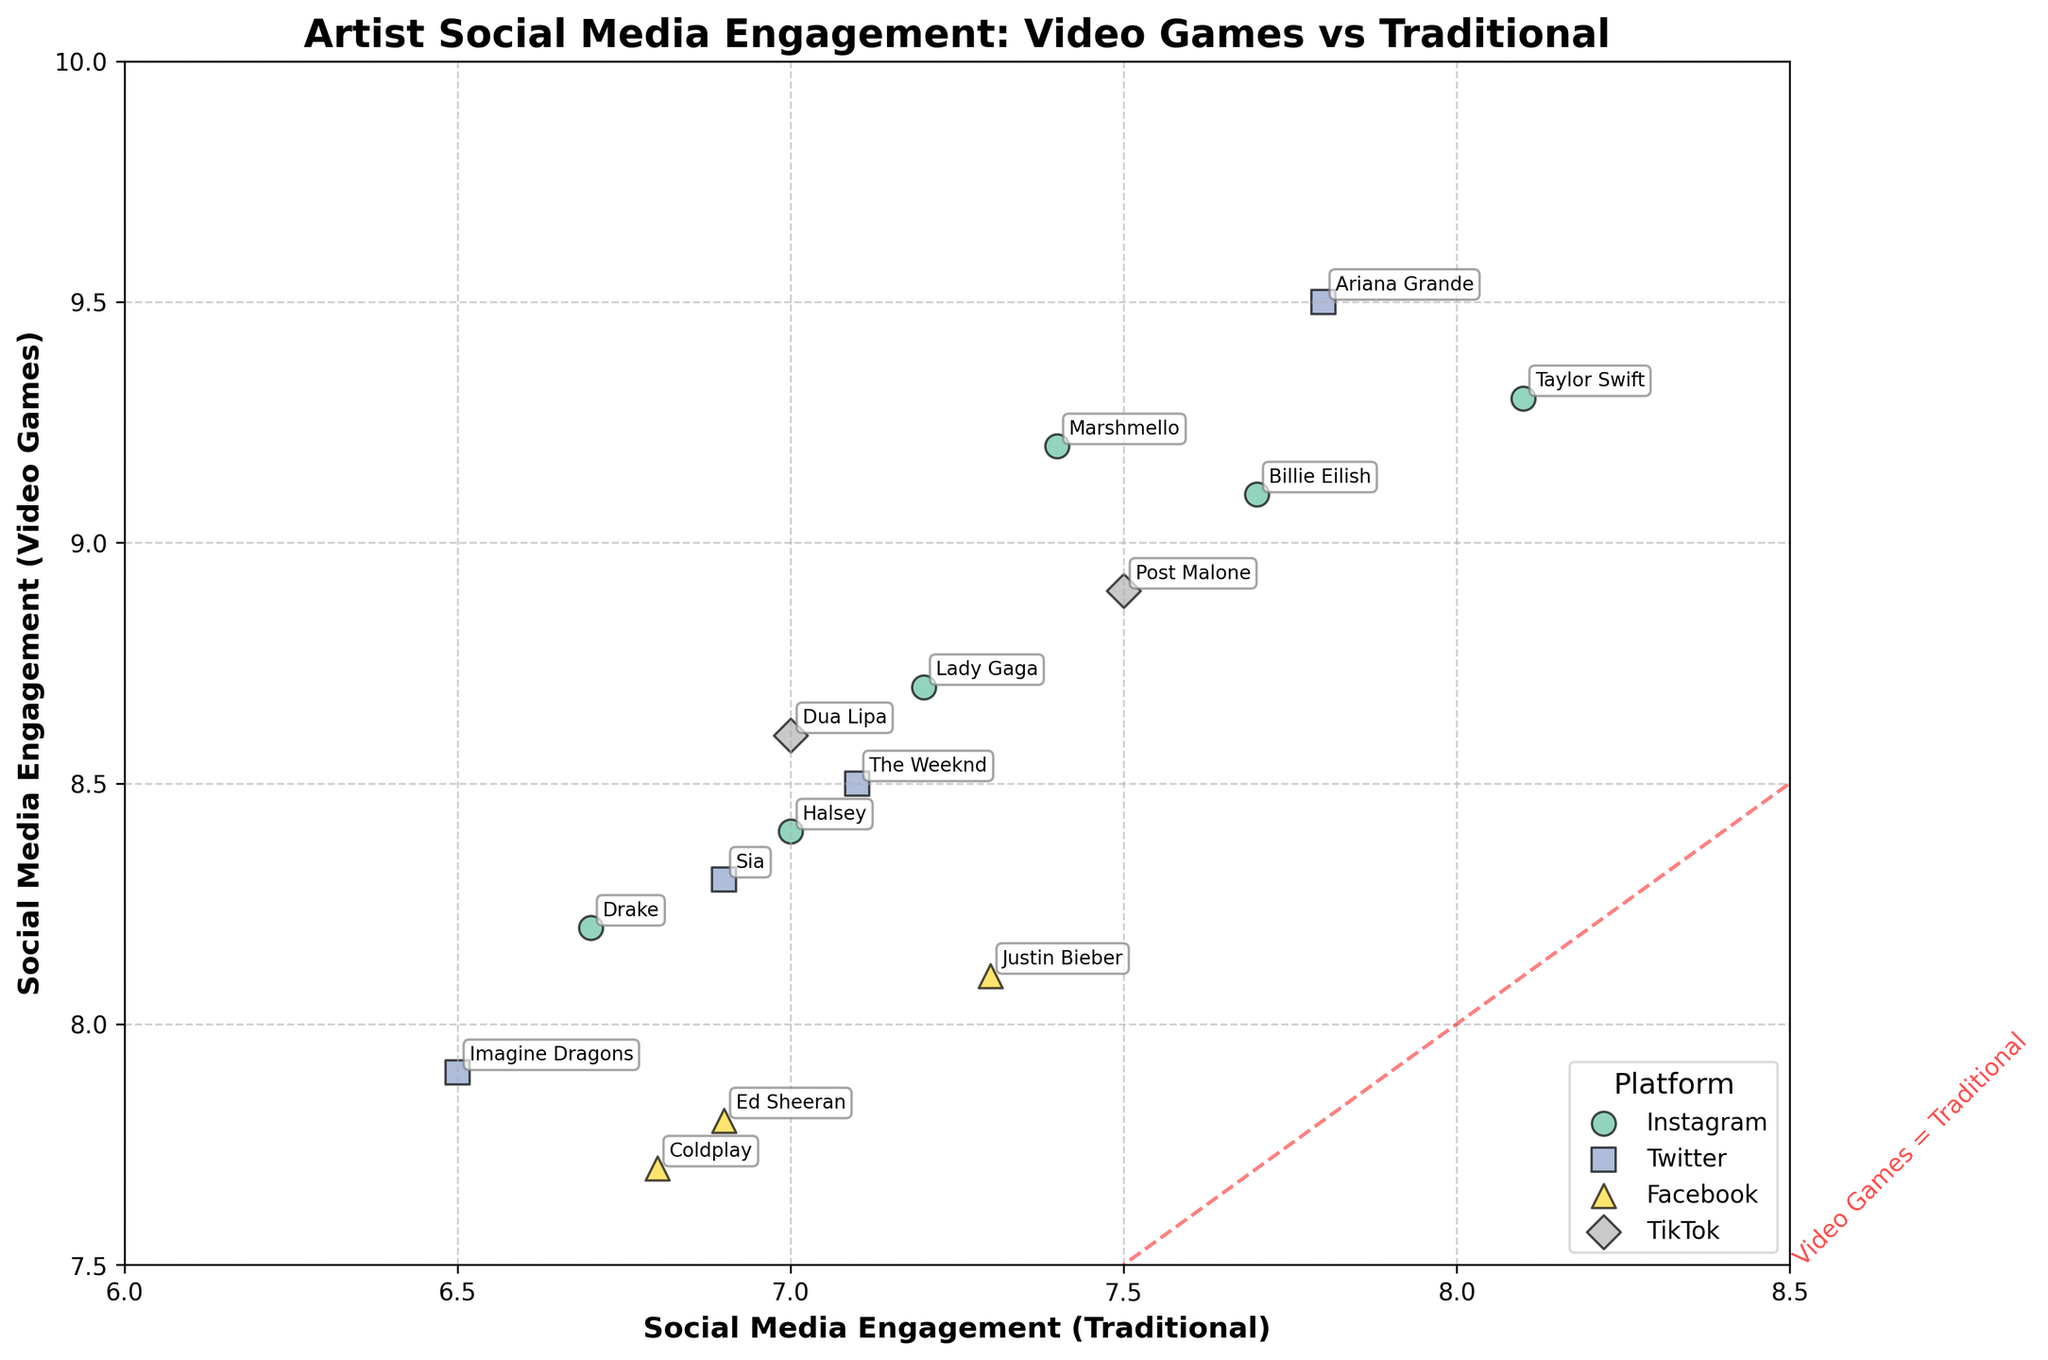How many data points are plotted for artists on Instagram? Count the number of artists associated with Instagram by checking the labels next to the points on the chart. There are 5 artists: Drake, Lady Gaga, Billie Eilish, Taylor Swift, and Marshmello.
Answer: 5 Which artist has the highest social media engagement rate from traditional methods? Review the plotted points and their labels along the horizontal axis (Social Media Engagement - Traditional). Taylor Swift has the highest engagement rate at 8.1.
Answer: Taylor Swift What is the average social media engagement rate for artists promoted through video games? Average the vertical coordinates (Video Game Engagement) of all points. Sum of engagement rates is (8.2 + 9.5 + 7.8 + 8.7 + 8.9 + 9.1 + 8.5 + 9.3 + 8.1 + 8.6 + 7.9 + 9.2 + 7.7 + 8.3 + 8.4) = 129.2. There are 15 data points, so the average is 129.2 / 15 = 8.613.
Answer: 8.61 How does social media engagement from video games compare to traditional methods for Imagine Dragons? Locate Imagine Dragons on the chart: their engagement rate with traditional promotion is 6.5 and with video games is 7.9. Video game engagement is higher (7.9 vs. 6.5).
Answer: Video game engagement is higher Which platform has the highest average video game engagement rate? Calculate the average engagement rate for each platform: 
Instagram: (8.2 + 8.7 + 9.1 + 9.3 + 9.2 + 8.4) / 6
Twitter: (9.5 + 8.5 + 7.9 + 8.3) / 4
Facebook: (7.8 + 8.1 + 7.7) / 3
TikTok: (8.9 + 8.6) / 2
The averages respectively are approximately: 
Instagram: 8.98, Twitter: 8.6, Facebook: 7.87, TikTok: 8.75. 
Instagram has the highest average.
Answer: Instagram Do any artists have equal engagement rates from both video games and traditional methods? Check if any data points lie exactly on the red dashed diagonal line indicated as "Video Games = Traditional". No data point is precisely on this line.
Answer: No Which platform does Drake use for social media engagement tracking in the chart? Look for Drake's label on the chart and note the color/marker for that data point, then refer to the legend. Drake uses Instagram.
Answer: Instagram 